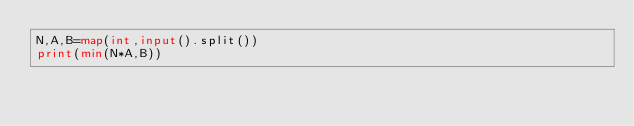<code> <loc_0><loc_0><loc_500><loc_500><_Python_>N,A,B=map(int,input().split())
print(min(N*A,B))
</code> 